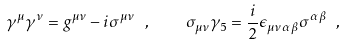Convert formula to latex. <formula><loc_0><loc_0><loc_500><loc_500>\gamma ^ { \mu } \gamma ^ { \nu } = g ^ { \mu \nu } - i \sigma ^ { \mu \nu } \ , \quad \sigma _ { \mu \nu } \gamma _ { 5 } = \frac { i } { 2 } \epsilon _ { \mu \nu \alpha \beta } \sigma ^ { \alpha \beta } \ ,</formula> 